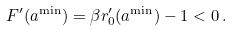Convert formula to latex. <formula><loc_0><loc_0><loc_500><loc_500>F ^ { \prime } ( a ^ { \min } ) = \beta r _ { 0 } ^ { \prime } ( a ^ { \min } ) - 1 < 0 \, .</formula> 